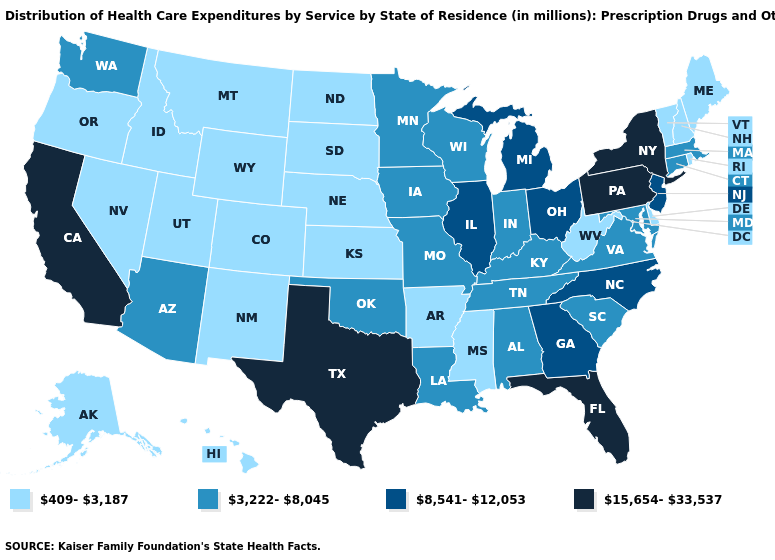Does the first symbol in the legend represent the smallest category?
Give a very brief answer. Yes. What is the value of Arkansas?
Quick response, please. 409-3,187. Among the states that border North Carolina , does Tennessee have the lowest value?
Give a very brief answer. Yes. How many symbols are there in the legend?
Answer briefly. 4. What is the value of New Mexico?
Short answer required. 409-3,187. Which states have the highest value in the USA?
Quick response, please. California, Florida, New York, Pennsylvania, Texas. Name the states that have a value in the range 409-3,187?
Answer briefly. Alaska, Arkansas, Colorado, Delaware, Hawaii, Idaho, Kansas, Maine, Mississippi, Montana, Nebraska, Nevada, New Hampshire, New Mexico, North Dakota, Oregon, Rhode Island, South Dakota, Utah, Vermont, West Virginia, Wyoming. Name the states that have a value in the range 409-3,187?
Answer briefly. Alaska, Arkansas, Colorado, Delaware, Hawaii, Idaho, Kansas, Maine, Mississippi, Montana, Nebraska, Nevada, New Hampshire, New Mexico, North Dakota, Oregon, Rhode Island, South Dakota, Utah, Vermont, West Virginia, Wyoming. What is the value of Connecticut?
Short answer required. 3,222-8,045. Does Vermont have the highest value in the Northeast?
Concise answer only. No. Name the states that have a value in the range 15,654-33,537?
Answer briefly. California, Florida, New York, Pennsylvania, Texas. Does Nevada have a lower value than Michigan?
Concise answer only. Yes. Does Rhode Island have a lower value than Wyoming?
Quick response, please. No. Does the map have missing data?
Keep it brief. No. What is the highest value in the USA?
Short answer required. 15,654-33,537. 